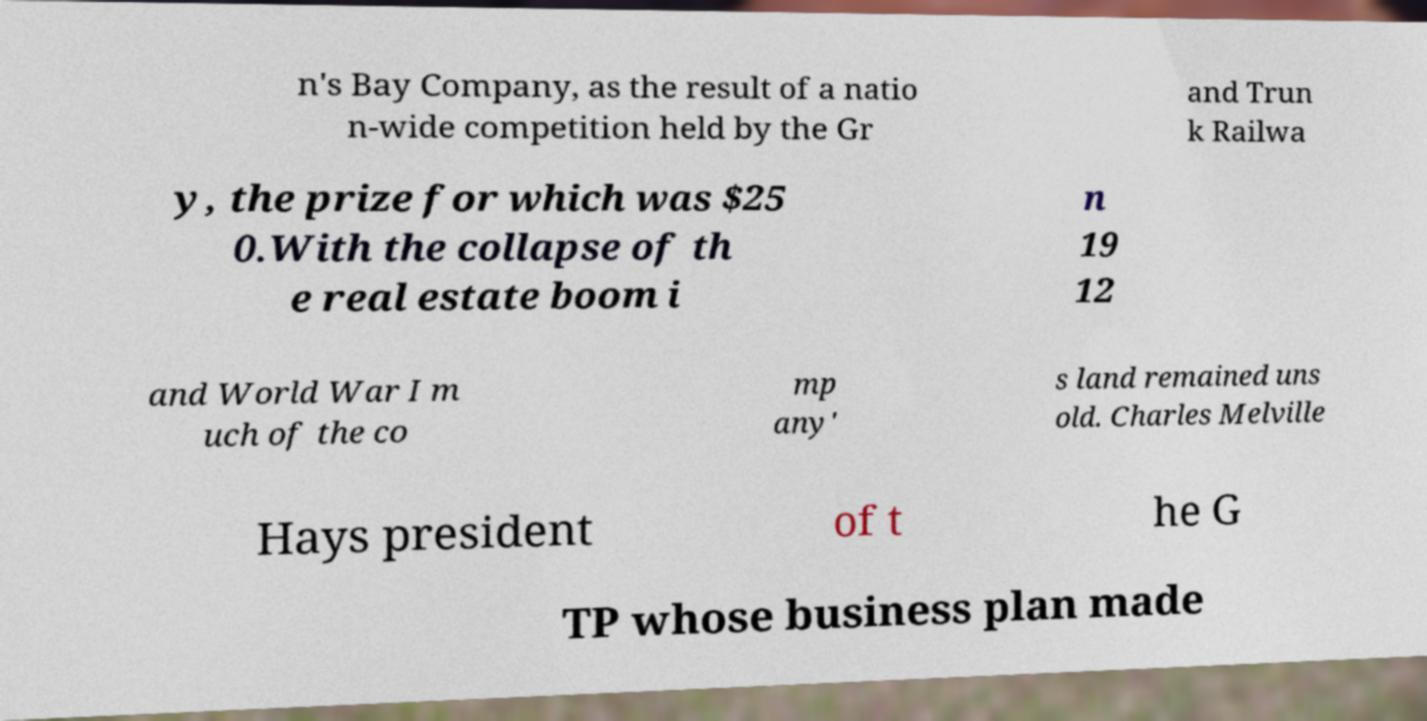I need the written content from this picture converted into text. Can you do that? n's Bay Company, as the result of a natio n-wide competition held by the Gr and Trun k Railwa y, the prize for which was $25 0.With the collapse of th e real estate boom i n 19 12 and World War I m uch of the co mp any' s land remained uns old. Charles Melville Hays president of t he G TP whose business plan made 